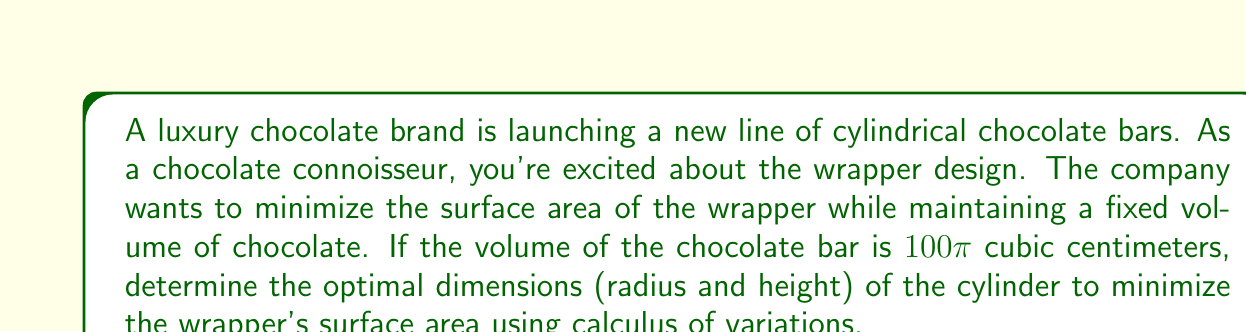Could you help me with this problem? Let's approach this problem step-by-step:

1) The surface area of a cylinder (including top and bottom) is given by:
   $$S = 2\pi r^2 + 2\pi rh$$
   where $r$ is the radius and $h$ is the height.

2) The volume of a cylinder is:
   $$V = \pi r^2h = 100\pi$$

3) We can express $h$ in terms of $r$ using the volume equation:
   $$h = \frac{100}{r^2}$$

4) Substituting this into the surface area equation:
   $$S = 2\pi r^2 + 2\pi r(\frac{100}{r^2}) = 2\pi r^2 + \frac{200\pi}{r}$$

5) To find the minimum, we differentiate $S$ with respect to $r$ and set it to zero:
   $$\frac{dS}{dr} = 4\pi r - \frac{200\pi}{r^2} = 0$$

6) Solving this equation:
   $$4\pi r^3 = 200\pi$$
   $$r^3 = 50$$
   $$r = \sqrt[3]{50} \approx 3.684$$

7) Now we can find $h$:
   $$h = \frac{100}{r^2} = \frac{100}{(\sqrt[3]{50})^2} = \frac{100}{\sqrt[3]{2500}} \approx 7.368$$

8) The minimum surface area can be calculated by substituting these values back into the surface area equation.
Answer: Optimal dimensions: $r \approx 3.684$ cm, $h \approx 7.368$ cm 